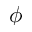Convert formula to latex. <formula><loc_0><loc_0><loc_500><loc_500>\phi</formula> 